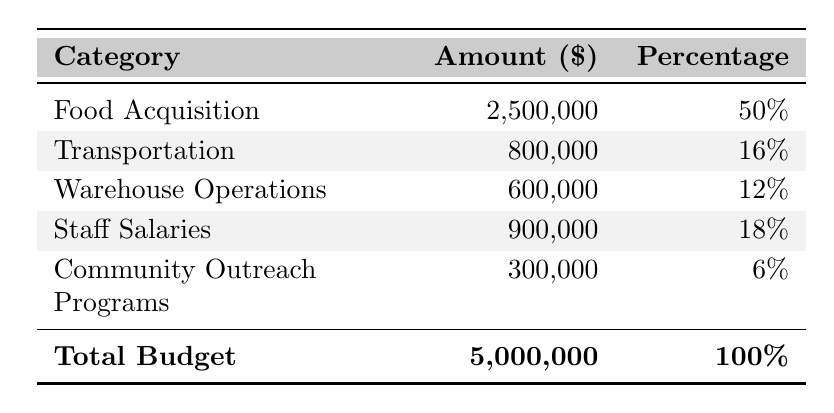What is the total operational budget for Gleaners Food Bank in 2022? The total budget is clearly stated in the table under 'Total Budget,' which shows the amount as 5,000,000.
Answer: 5,000,000 What amount is allocated to Food Acquisition? The allocation for Food Acquisition is given in the 'Amount' column next to the 'Food Acquisition' category, which shows 2,500,000.
Answer: 2,500,000 What percentage of the total budget is allocated to Transportation? The 'Percentage' column next to the Transportation line indicates that 16% of the total budget is allocated to this category.
Answer: 16% Is the budget for Community Outreach Programs greater than Staff Salaries? Comparing the amounts listed, 300,000 for Community Outreach Programs is less than 900,000 for Staff Salaries, so the statement is false.
Answer: No Which category receives the highest allocation? The table indicates that Food Acquisition has the highest allocation amount of 2,500,000.
Answer: Food Acquisition What is the total amount allocated for Warehouse Operations and Community Outreach Programs combined? To find the total amount, we add the allocations: 600,000 (Warehouse Operations) + 300,000 (Community Outreach Programs) = 900,000.
Answer: 900,000 What percentage does Staff Salaries represent of the total budget? The 'Percentage' for Staff Salaries is directly mentioned in the table as 18%.
Answer: 18% How much less is allocated to Transportation compared to Food Acquisition? To find the difference, subtract the Transportation amount (800,000) from the Food Acquisition amount (2,500,000): 2,500,000 - 800,000 = 1,700,000.
Answer: 1,700,000 If the organization decided to increase the budget for Community Outreach Programs by 100,000, what would the new percentage be? The new amount would be 300,000 + 100,000 = 400,000. The new total budget will still be 5,000,000, so the new percentage is (400,000 / 5,000,000) * 100 = 8%.
Answer: 8% What is the ratio of the funding allocated to Transportation compared to Food Acquisition? The amounts are 800,000 for Transportation and 2,500,000 for Food Acquisition. The ratio is 800,000:2,500,000, which simplifies to 8:25.
Answer: 8:25 